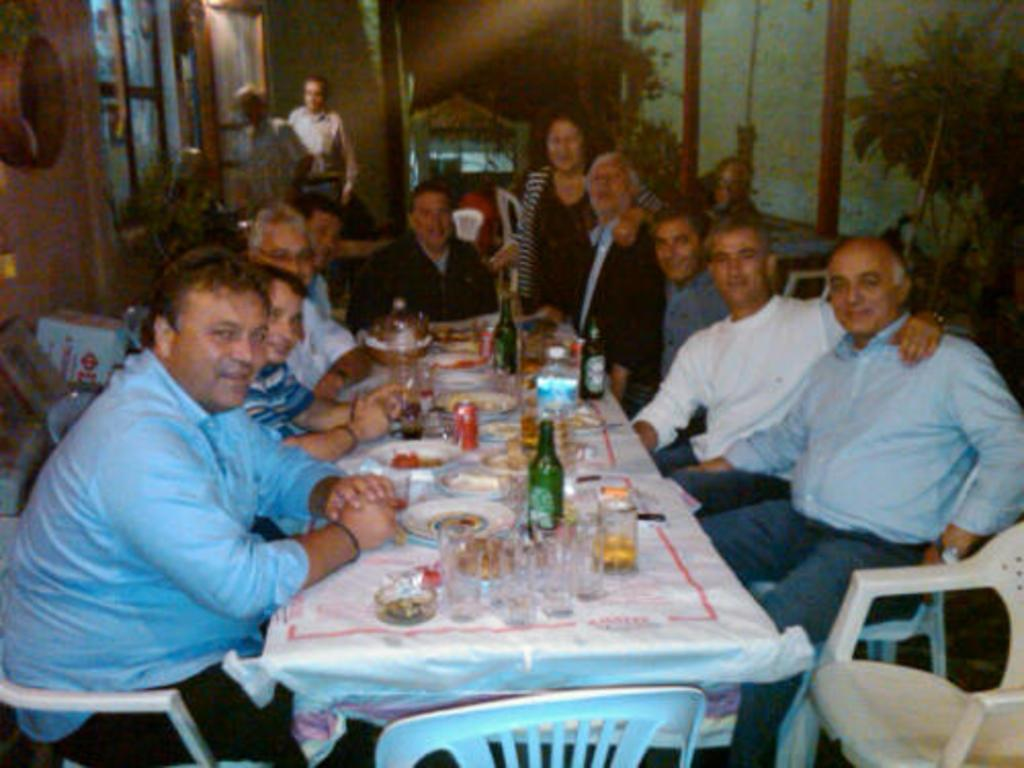What is happening in the image involving a group of people? There is a group of people in the image, and they are sitting on chairs and having food. Can you describe the positions of the people in the image? The people are sitting on chairs, and there are two persons standing in the top left of the image. What type of throne is visible in the image? There is no throne present in the image. What surprise event is happening in the image? There is no surprise event happening in the image; it simply shows a group of people sitting and having food. 